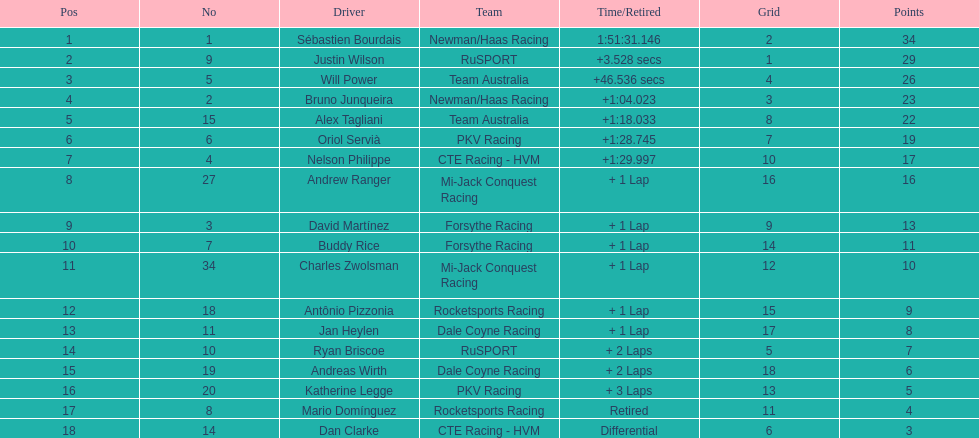Which country had more drivers representing them, the us or germany? Tie. 